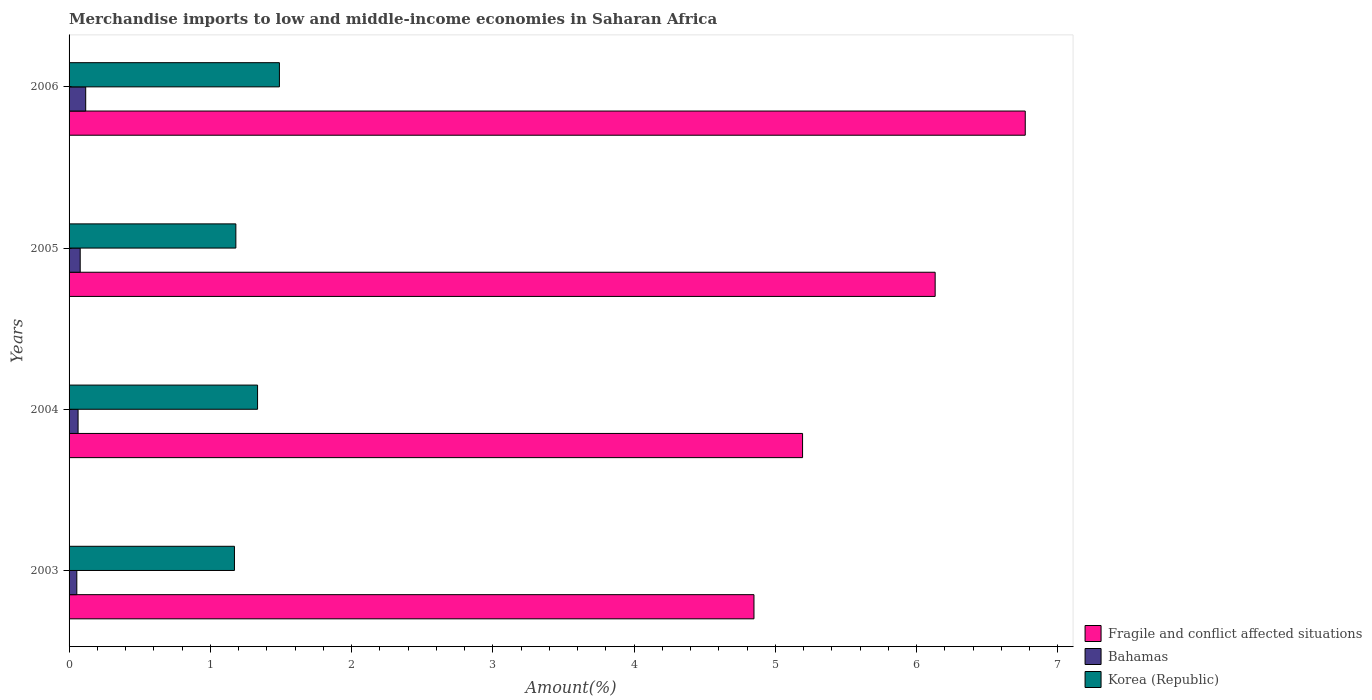Are the number of bars per tick equal to the number of legend labels?
Offer a terse response. Yes. Are the number of bars on each tick of the Y-axis equal?
Your answer should be compact. Yes. How many bars are there on the 4th tick from the bottom?
Your answer should be very brief. 3. What is the label of the 1st group of bars from the top?
Your answer should be compact. 2006. In how many cases, is the number of bars for a given year not equal to the number of legend labels?
Offer a terse response. 0. What is the percentage of amount earned from merchandise imports in Bahamas in 2005?
Provide a short and direct response. 0.08. Across all years, what is the maximum percentage of amount earned from merchandise imports in Fragile and conflict affected situations?
Provide a short and direct response. 6.77. Across all years, what is the minimum percentage of amount earned from merchandise imports in Fragile and conflict affected situations?
Your answer should be very brief. 4.85. In which year was the percentage of amount earned from merchandise imports in Korea (Republic) maximum?
Offer a very short reply. 2006. What is the total percentage of amount earned from merchandise imports in Korea (Republic) in the graph?
Your answer should be compact. 5.17. What is the difference between the percentage of amount earned from merchandise imports in Fragile and conflict affected situations in 2005 and that in 2006?
Provide a short and direct response. -0.64. What is the difference between the percentage of amount earned from merchandise imports in Bahamas in 2006 and the percentage of amount earned from merchandise imports in Korea (Republic) in 2005?
Offer a terse response. -1.06. What is the average percentage of amount earned from merchandise imports in Fragile and conflict affected situations per year?
Offer a terse response. 5.73. In the year 2005, what is the difference between the percentage of amount earned from merchandise imports in Bahamas and percentage of amount earned from merchandise imports in Fragile and conflict affected situations?
Your answer should be very brief. -6.05. In how many years, is the percentage of amount earned from merchandise imports in Bahamas greater than 3.8 %?
Provide a succinct answer. 0. What is the ratio of the percentage of amount earned from merchandise imports in Fragile and conflict affected situations in 2004 to that in 2006?
Make the answer very short. 0.77. Is the percentage of amount earned from merchandise imports in Korea (Republic) in 2003 less than that in 2004?
Offer a very short reply. Yes. Is the difference between the percentage of amount earned from merchandise imports in Bahamas in 2003 and 2005 greater than the difference between the percentage of amount earned from merchandise imports in Fragile and conflict affected situations in 2003 and 2005?
Ensure brevity in your answer.  Yes. What is the difference between the highest and the second highest percentage of amount earned from merchandise imports in Bahamas?
Offer a terse response. 0.04. What is the difference between the highest and the lowest percentage of amount earned from merchandise imports in Bahamas?
Give a very brief answer. 0.06. In how many years, is the percentage of amount earned from merchandise imports in Fragile and conflict affected situations greater than the average percentage of amount earned from merchandise imports in Fragile and conflict affected situations taken over all years?
Provide a succinct answer. 2. What does the 1st bar from the top in 2005 represents?
Make the answer very short. Korea (Republic). What does the 1st bar from the bottom in 2004 represents?
Make the answer very short. Fragile and conflict affected situations. How many bars are there?
Make the answer very short. 12. How many years are there in the graph?
Offer a terse response. 4. Does the graph contain grids?
Your response must be concise. No. What is the title of the graph?
Keep it short and to the point. Merchandise imports to low and middle-income economies in Saharan Africa. Does "Lesotho" appear as one of the legend labels in the graph?
Offer a very short reply. No. What is the label or title of the X-axis?
Provide a succinct answer. Amount(%). What is the label or title of the Y-axis?
Offer a terse response. Years. What is the Amount(%) in Fragile and conflict affected situations in 2003?
Your answer should be compact. 4.85. What is the Amount(%) of Bahamas in 2003?
Your answer should be compact. 0.05. What is the Amount(%) in Korea (Republic) in 2003?
Give a very brief answer. 1.17. What is the Amount(%) in Fragile and conflict affected situations in 2004?
Give a very brief answer. 5.19. What is the Amount(%) of Bahamas in 2004?
Make the answer very short. 0.06. What is the Amount(%) of Korea (Republic) in 2004?
Provide a succinct answer. 1.33. What is the Amount(%) in Fragile and conflict affected situations in 2005?
Your answer should be compact. 6.13. What is the Amount(%) of Bahamas in 2005?
Your answer should be very brief. 0.08. What is the Amount(%) of Korea (Republic) in 2005?
Keep it short and to the point. 1.18. What is the Amount(%) of Fragile and conflict affected situations in 2006?
Your response must be concise. 6.77. What is the Amount(%) in Bahamas in 2006?
Provide a short and direct response. 0.12. What is the Amount(%) of Korea (Republic) in 2006?
Provide a short and direct response. 1.49. Across all years, what is the maximum Amount(%) of Fragile and conflict affected situations?
Keep it short and to the point. 6.77. Across all years, what is the maximum Amount(%) of Bahamas?
Your answer should be very brief. 0.12. Across all years, what is the maximum Amount(%) of Korea (Republic)?
Provide a succinct answer. 1.49. Across all years, what is the minimum Amount(%) in Fragile and conflict affected situations?
Provide a short and direct response. 4.85. Across all years, what is the minimum Amount(%) in Bahamas?
Your response must be concise. 0.05. Across all years, what is the minimum Amount(%) of Korea (Republic)?
Keep it short and to the point. 1.17. What is the total Amount(%) in Fragile and conflict affected situations in the graph?
Keep it short and to the point. 22.94. What is the total Amount(%) of Bahamas in the graph?
Make the answer very short. 0.32. What is the total Amount(%) of Korea (Republic) in the graph?
Keep it short and to the point. 5.17. What is the difference between the Amount(%) in Fragile and conflict affected situations in 2003 and that in 2004?
Provide a succinct answer. -0.34. What is the difference between the Amount(%) of Bahamas in 2003 and that in 2004?
Ensure brevity in your answer.  -0.01. What is the difference between the Amount(%) of Korea (Republic) in 2003 and that in 2004?
Offer a very short reply. -0.16. What is the difference between the Amount(%) in Fragile and conflict affected situations in 2003 and that in 2005?
Provide a succinct answer. -1.28. What is the difference between the Amount(%) of Bahamas in 2003 and that in 2005?
Make the answer very short. -0.02. What is the difference between the Amount(%) in Korea (Republic) in 2003 and that in 2005?
Give a very brief answer. -0.01. What is the difference between the Amount(%) in Fragile and conflict affected situations in 2003 and that in 2006?
Provide a succinct answer. -1.92. What is the difference between the Amount(%) in Bahamas in 2003 and that in 2006?
Offer a terse response. -0.06. What is the difference between the Amount(%) in Korea (Republic) in 2003 and that in 2006?
Provide a short and direct response. -0.32. What is the difference between the Amount(%) of Fragile and conflict affected situations in 2004 and that in 2005?
Provide a succinct answer. -0.94. What is the difference between the Amount(%) of Bahamas in 2004 and that in 2005?
Offer a very short reply. -0.01. What is the difference between the Amount(%) of Korea (Republic) in 2004 and that in 2005?
Keep it short and to the point. 0.15. What is the difference between the Amount(%) in Fragile and conflict affected situations in 2004 and that in 2006?
Give a very brief answer. -1.58. What is the difference between the Amount(%) in Bahamas in 2004 and that in 2006?
Offer a very short reply. -0.05. What is the difference between the Amount(%) of Korea (Republic) in 2004 and that in 2006?
Your answer should be compact. -0.15. What is the difference between the Amount(%) of Fragile and conflict affected situations in 2005 and that in 2006?
Make the answer very short. -0.64. What is the difference between the Amount(%) in Bahamas in 2005 and that in 2006?
Offer a very short reply. -0.04. What is the difference between the Amount(%) in Korea (Republic) in 2005 and that in 2006?
Keep it short and to the point. -0.31. What is the difference between the Amount(%) in Fragile and conflict affected situations in 2003 and the Amount(%) in Bahamas in 2004?
Your response must be concise. 4.78. What is the difference between the Amount(%) of Fragile and conflict affected situations in 2003 and the Amount(%) of Korea (Republic) in 2004?
Keep it short and to the point. 3.51. What is the difference between the Amount(%) of Bahamas in 2003 and the Amount(%) of Korea (Republic) in 2004?
Provide a short and direct response. -1.28. What is the difference between the Amount(%) of Fragile and conflict affected situations in 2003 and the Amount(%) of Bahamas in 2005?
Your answer should be compact. 4.77. What is the difference between the Amount(%) of Fragile and conflict affected situations in 2003 and the Amount(%) of Korea (Republic) in 2005?
Provide a succinct answer. 3.67. What is the difference between the Amount(%) of Bahamas in 2003 and the Amount(%) of Korea (Republic) in 2005?
Offer a terse response. -1.13. What is the difference between the Amount(%) of Fragile and conflict affected situations in 2003 and the Amount(%) of Bahamas in 2006?
Your response must be concise. 4.73. What is the difference between the Amount(%) of Fragile and conflict affected situations in 2003 and the Amount(%) of Korea (Republic) in 2006?
Your response must be concise. 3.36. What is the difference between the Amount(%) in Bahamas in 2003 and the Amount(%) in Korea (Republic) in 2006?
Provide a succinct answer. -1.43. What is the difference between the Amount(%) in Fragile and conflict affected situations in 2004 and the Amount(%) in Bahamas in 2005?
Your answer should be compact. 5.11. What is the difference between the Amount(%) of Fragile and conflict affected situations in 2004 and the Amount(%) of Korea (Republic) in 2005?
Your response must be concise. 4.01. What is the difference between the Amount(%) in Bahamas in 2004 and the Amount(%) in Korea (Republic) in 2005?
Keep it short and to the point. -1.12. What is the difference between the Amount(%) of Fragile and conflict affected situations in 2004 and the Amount(%) of Bahamas in 2006?
Provide a short and direct response. 5.07. What is the difference between the Amount(%) in Fragile and conflict affected situations in 2004 and the Amount(%) in Korea (Republic) in 2006?
Ensure brevity in your answer.  3.7. What is the difference between the Amount(%) of Bahamas in 2004 and the Amount(%) of Korea (Republic) in 2006?
Your answer should be compact. -1.43. What is the difference between the Amount(%) of Fragile and conflict affected situations in 2005 and the Amount(%) of Bahamas in 2006?
Your answer should be very brief. 6.01. What is the difference between the Amount(%) in Fragile and conflict affected situations in 2005 and the Amount(%) in Korea (Republic) in 2006?
Offer a terse response. 4.64. What is the difference between the Amount(%) in Bahamas in 2005 and the Amount(%) in Korea (Republic) in 2006?
Ensure brevity in your answer.  -1.41. What is the average Amount(%) of Fragile and conflict affected situations per year?
Your response must be concise. 5.73. What is the average Amount(%) of Bahamas per year?
Provide a short and direct response. 0.08. What is the average Amount(%) in Korea (Republic) per year?
Provide a short and direct response. 1.29. In the year 2003, what is the difference between the Amount(%) of Fragile and conflict affected situations and Amount(%) of Bahamas?
Offer a terse response. 4.79. In the year 2003, what is the difference between the Amount(%) of Fragile and conflict affected situations and Amount(%) of Korea (Republic)?
Your response must be concise. 3.68. In the year 2003, what is the difference between the Amount(%) of Bahamas and Amount(%) of Korea (Republic)?
Offer a very short reply. -1.12. In the year 2004, what is the difference between the Amount(%) of Fragile and conflict affected situations and Amount(%) of Bahamas?
Provide a succinct answer. 5.13. In the year 2004, what is the difference between the Amount(%) in Fragile and conflict affected situations and Amount(%) in Korea (Republic)?
Your answer should be compact. 3.86. In the year 2004, what is the difference between the Amount(%) of Bahamas and Amount(%) of Korea (Republic)?
Your response must be concise. -1.27. In the year 2005, what is the difference between the Amount(%) of Fragile and conflict affected situations and Amount(%) of Bahamas?
Give a very brief answer. 6.05. In the year 2005, what is the difference between the Amount(%) of Fragile and conflict affected situations and Amount(%) of Korea (Republic)?
Your answer should be very brief. 4.95. In the year 2005, what is the difference between the Amount(%) in Bahamas and Amount(%) in Korea (Republic)?
Make the answer very short. -1.1. In the year 2006, what is the difference between the Amount(%) in Fragile and conflict affected situations and Amount(%) in Bahamas?
Provide a short and direct response. 6.65. In the year 2006, what is the difference between the Amount(%) of Fragile and conflict affected situations and Amount(%) of Korea (Republic)?
Keep it short and to the point. 5.28. In the year 2006, what is the difference between the Amount(%) of Bahamas and Amount(%) of Korea (Republic)?
Offer a terse response. -1.37. What is the ratio of the Amount(%) of Fragile and conflict affected situations in 2003 to that in 2004?
Make the answer very short. 0.93. What is the ratio of the Amount(%) in Bahamas in 2003 to that in 2004?
Your answer should be very brief. 0.86. What is the ratio of the Amount(%) of Korea (Republic) in 2003 to that in 2004?
Keep it short and to the point. 0.88. What is the ratio of the Amount(%) of Fragile and conflict affected situations in 2003 to that in 2005?
Provide a succinct answer. 0.79. What is the ratio of the Amount(%) of Bahamas in 2003 to that in 2005?
Your answer should be very brief. 0.7. What is the ratio of the Amount(%) of Korea (Republic) in 2003 to that in 2005?
Give a very brief answer. 0.99. What is the ratio of the Amount(%) of Fragile and conflict affected situations in 2003 to that in 2006?
Ensure brevity in your answer.  0.72. What is the ratio of the Amount(%) in Bahamas in 2003 to that in 2006?
Your response must be concise. 0.47. What is the ratio of the Amount(%) of Korea (Republic) in 2003 to that in 2006?
Offer a very short reply. 0.79. What is the ratio of the Amount(%) of Fragile and conflict affected situations in 2004 to that in 2005?
Your answer should be compact. 0.85. What is the ratio of the Amount(%) in Bahamas in 2004 to that in 2005?
Give a very brief answer. 0.81. What is the ratio of the Amount(%) of Korea (Republic) in 2004 to that in 2005?
Your answer should be very brief. 1.13. What is the ratio of the Amount(%) of Fragile and conflict affected situations in 2004 to that in 2006?
Keep it short and to the point. 0.77. What is the ratio of the Amount(%) of Bahamas in 2004 to that in 2006?
Provide a succinct answer. 0.54. What is the ratio of the Amount(%) of Korea (Republic) in 2004 to that in 2006?
Offer a very short reply. 0.9. What is the ratio of the Amount(%) of Fragile and conflict affected situations in 2005 to that in 2006?
Make the answer very short. 0.91. What is the ratio of the Amount(%) in Bahamas in 2005 to that in 2006?
Provide a succinct answer. 0.67. What is the ratio of the Amount(%) in Korea (Republic) in 2005 to that in 2006?
Provide a short and direct response. 0.79. What is the difference between the highest and the second highest Amount(%) in Fragile and conflict affected situations?
Your answer should be compact. 0.64. What is the difference between the highest and the second highest Amount(%) in Bahamas?
Provide a short and direct response. 0.04. What is the difference between the highest and the second highest Amount(%) of Korea (Republic)?
Provide a short and direct response. 0.15. What is the difference between the highest and the lowest Amount(%) of Fragile and conflict affected situations?
Your answer should be very brief. 1.92. What is the difference between the highest and the lowest Amount(%) in Bahamas?
Your answer should be very brief. 0.06. What is the difference between the highest and the lowest Amount(%) of Korea (Republic)?
Your answer should be very brief. 0.32. 